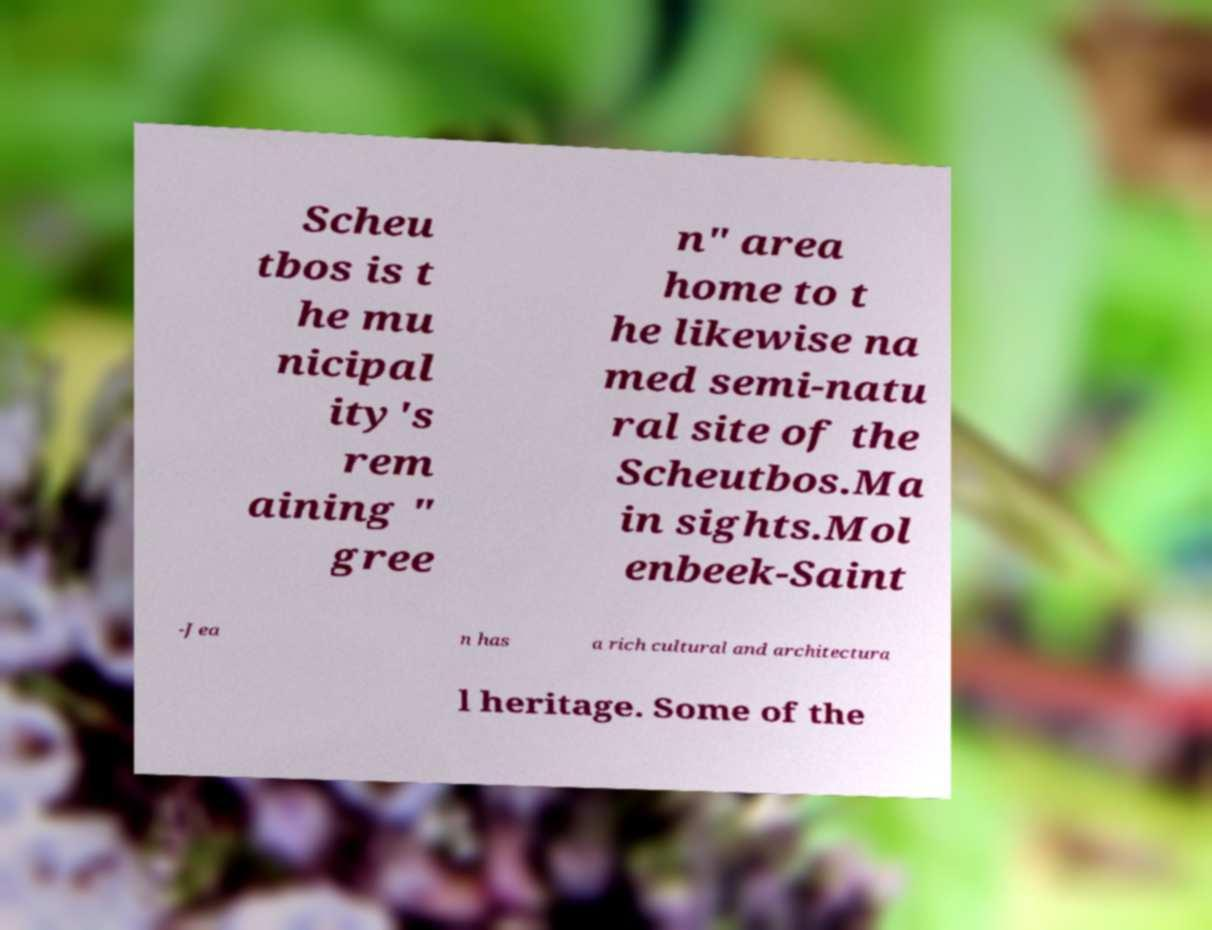I need the written content from this picture converted into text. Can you do that? Scheu tbos is t he mu nicipal ity's rem aining " gree n" area home to t he likewise na med semi-natu ral site of the Scheutbos.Ma in sights.Mol enbeek-Saint -Jea n has a rich cultural and architectura l heritage. Some of the 